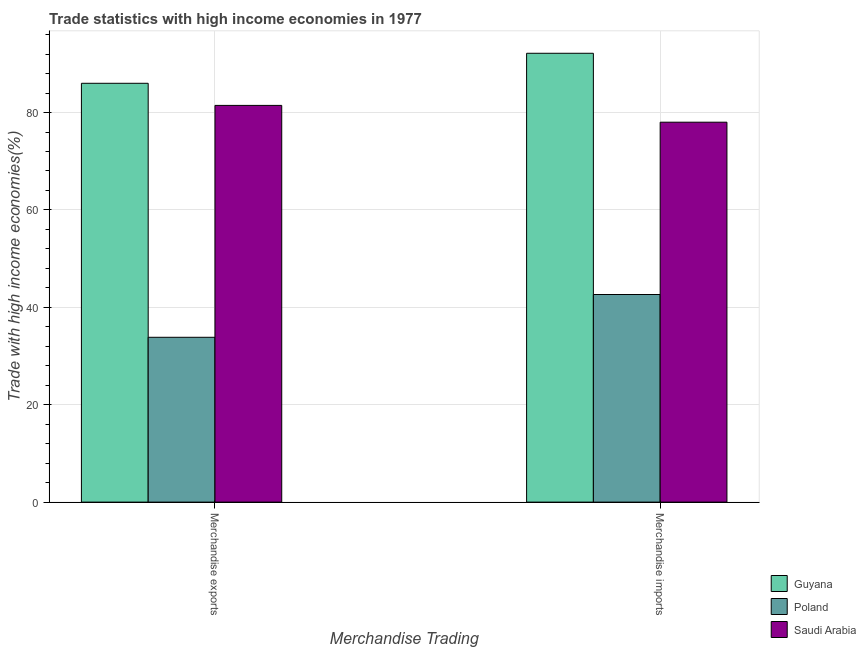How many different coloured bars are there?
Your answer should be compact. 3. How many groups of bars are there?
Your response must be concise. 2. How many bars are there on the 1st tick from the right?
Your answer should be very brief. 3. What is the label of the 2nd group of bars from the left?
Ensure brevity in your answer.  Merchandise imports. What is the merchandise exports in Poland?
Your response must be concise. 33.85. Across all countries, what is the maximum merchandise imports?
Your answer should be compact. 92.17. Across all countries, what is the minimum merchandise imports?
Your response must be concise. 42.63. In which country was the merchandise imports maximum?
Ensure brevity in your answer.  Guyana. In which country was the merchandise exports minimum?
Make the answer very short. Poland. What is the total merchandise exports in the graph?
Offer a terse response. 201.32. What is the difference between the merchandise imports in Poland and that in Saudi Arabia?
Make the answer very short. -35.38. What is the difference between the merchandise exports in Poland and the merchandise imports in Guyana?
Make the answer very short. -58.32. What is the average merchandise imports per country?
Make the answer very short. 70.94. What is the difference between the merchandise imports and merchandise exports in Saudi Arabia?
Your response must be concise. -3.45. In how many countries, is the merchandise exports greater than 40 %?
Make the answer very short. 2. What is the ratio of the merchandise imports in Poland to that in Guyana?
Provide a succinct answer. 0.46. In how many countries, is the merchandise exports greater than the average merchandise exports taken over all countries?
Offer a terse response. 2. What does the 1st bar from the right in Merchandise exports represents?
Your answer should be compact. Saudi Arabia. Are all the bars in the graph horizontal?
Provide a short and direct response. No. How many countries are there in the graph?
Give a very brief answer. 3. Where does the legend appear in the graph?
Your response must be concise. Bottom right. How many legend labels are there?
Give a very brief answer. 3. What is the title of the graph?
Your answer should be compact. Trade statistics with high income economies in 1977. What is the label or title of the X-axis?
Your answer should be compact. Merchandise Trading. What is the label or title of the Y-axis?
Give a very brief answer. Trade with high income economies(%). What is the Trade with high income economies(%) in Guyana in Merchandise exports?
Make the answer very short. 86. What is the Trade with high income economies(%) in Poland in Merchandise exports?
Give a very brief answer. 33.85. What is the Trade with high income economies(%) of Saudi Arabia in Merchandise exports?
Provide a short and direct response. 81.47. What is the Trade with high income economies(%) in Guyana in Merchandise imports?
Your answer should be compact. 92.17. What is the Trade with high income economies(%) of Poland in Merchandise imports?
Provide a short and direct response. 42.63. What is the Trade with high income economies(%) of Saudi Arabia in Merchandise imports?
Your answer should be compact. 78.01. Across all Merchandise Trading, what is the maximum Trade with high income economies(%) in Guyana?
Provide a short and direct response. 92.17. Across all Merchandise Trading, what is the maximum Trade with high income economies(%) of Poland?
Provide a short and direct response. 42.63. Across all Merchandise Trading, what is the maximum Trade with high income economies(%) of Saudi Arabia?
Your response must be concise. 81.47. Across all Merchandise Trading, what is the minimum Trade with high income economies(%) of Guyana?
Make the answer very short. 86. Across all Merchandise Trading, what is the minimum Trade with high income economies(%) of Poland?
Offer a very short reply. 33.85. Across all Merchandise Trading, what is the minimum Trade with high income economies(%) in Saudi Arabia?
Keep it short and to the point. 78.01. What is the total Trade with high income economies(%) of Guyana in the graph?
Your response must be concise. 178.17. What is the total Trade with high income economies(%) in Poland in the graph?
Your answer should be compact. 76.48. What is the total Trade with high income economies(%) in Saudi Arabia in the graph?
Make the answer very short. 159.48. What is the difference between the Trade with high income economies(%) in Guyana in Merchandise exports and that in Merchandise imports?
Offer a terse response. -6.16. What is the difference between the Trade with high income economies(%) in Poland in Merchandise exports and that in Merchandise imports?
Make the answer very short. -8.78. What is the difference between the Trade with high income economies(%) in Saudi Arabia in Merchandise exports and that in Merchandise imports?
Offer a terse response. 3.45. What is the difference between the Trade with high income economies(%) of Guyana in Merchandise exports and the Trade with high income economies(%) of Poland in Merchandise imports?
Offer a very short reply. 43.37. What is the difference between the Trade with high income economies(%) of Guyana in Merchandise exports and the Trade with high income economies(%) of Saudi Arabia in Merchandise imports?
Ensure brevity in your answer.  7.99. What is the difference between the Trade with high income economies(%) of Poland in Merchandise exports and the Trade with high income economies(%) of Saudi Arabia in Merchandise imports?
Your response must be concise. -44.17. What is the average Trade with high income economies(%) of Guyana per Merchandise Trading?
Your answer should be very brief. 89.09. What is the average Trade with high income economies(%) of Poland per Merchandise Trading?
Offer a very short reply. 38.24. What is the average Trade with high income economies(%) in Saudi Arabia per Merchandise Trading?
Your answer should be very brief. 79.74. What is the difference between the Trade with high income economies(%) of Guyana and Trade with high income economies(%) of Poland in Merchandise exports?
Keep it short and to the point. 52.16. What is the difference between the Trade with high income economies(%) in Guyana and Trade with high income economies(%) in Saudi Arabia in Merchandise exports?
Your answer should be compact. 4.54. What is the difference between the Trade with high income economies(%) of Poland and Trade with high income economies(%) of Saudi Arabia in Merchandise exports?
Provide a succinct answer. -47.62. What is the difference between the Trade with high income economies(%) of Guyana and Trade with high income economies(%) of Poland in Merchandise imports?
Your response must be concise. 49.54. What is the difference between the Trade with high income economies(%) in Guyana and Trade with high income economies(%) in Saudi Arabia in Merchandise imports?
Make the answer very short. 14.15. What is the difference between the Trade with high income economies(%) in Poland and Trade with high income economies(%) in Saudi Arabia in Merchandise imports?
Your response must be concise. -35.38. What is the ratio of the Trade with high income economies(%) of Guyana in Merchandise exports to that in Merchandise imports?
Provide a short and direct response. 0.93. What is the ratio of the Trade with high income economies(%) in Poland in Merchandise exports to that in Merchandise imports?
Your answer should be very brief. 0.79. What is the ratio of the Trade with high income economies(%) of Saudi Arabia in Merchandise exports to that in Merchandise imports?
Offer a very short reply. 1.04. What is the difference between the highest and the second highest Trade with high income economies(%) of Guyana?
Make the answer very short. 6.16. What is the difference between the highest and the second highest Trade with high income economies(%) of Poland?
Offer a very short reply. 8.78. What is the difference between the highest and the second highest Trade with high income economies(%) in Saudi Arabia?
Your answer should be very brief. 3.45. What is the difference between the highest and the lowest Trade with high income economies(%) in Guyana?
Give a very brief answer. 6.16. What is the difference between the highest and the lowest Trade with high income economies(%) in Poland?
Your response must be concise. 8.78. What is the difference between the highest and the lowest Trade with high income economies(%) of Saudi Arabia?
Offer a terse response. 3.45. 